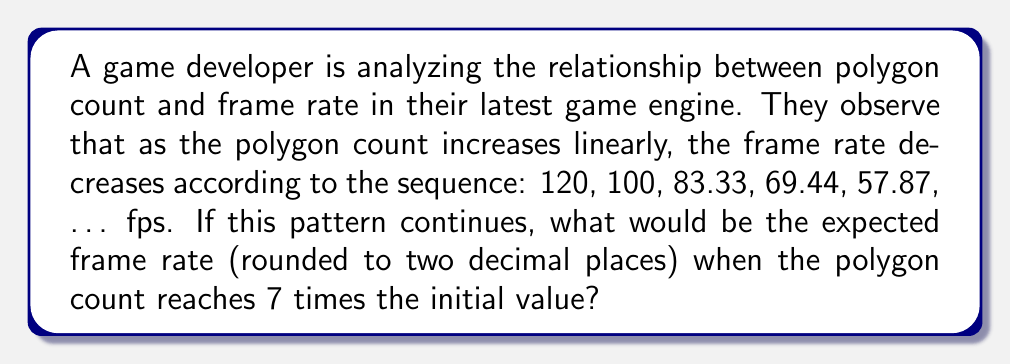Help me with this question. Let's approach this step-by-step:

1) First, we need to identify the pattern in the given sequence. Let's calculate the ratio between consecutive terms:

   $\frac{100}{120} = \frac{5}{6}$
   $\frac{83.33}{100} = \frac{5}{6}$
   $\frac{69.44}{83.33} = \frac{5}{6}$
   $\frac{57.87}{69.44} = \frac{5}{6}$

2) We can see that each term is $\frac{5}{6}$ of the previous term. This is a geometric sequence with a common ratio of $\frac{5}{6}$.

3) The general term of a geometric sequence is given by:

   $a_n = a_1 \cdot r^{n-1}$

   Where $a_1$ is the first term, $r$ is the common ratio, and $n$ is the term number.

4) In this case, $a_1 = 120$ and $r = \frac{5}{6}$

5) We need to find the 7th term of this sequence (as the polygon count reaches 7 times the initial value). So, $n = 7$

6) Plugging these values into our formula:

   $a_7 = 120 \cdot (\frac{5}{6})^{7-1}$

7) Simplifying:

   $a_7 = 120 \cdot (\frac{5}{6})^6$

8) Calculating:

   $a_7 = 120 \cdot 0.33489 = 40.18688$

9) Rounding to two decimal places:

   $a_7 \approx 40.19$ fps
Answer: 40.19 fps 